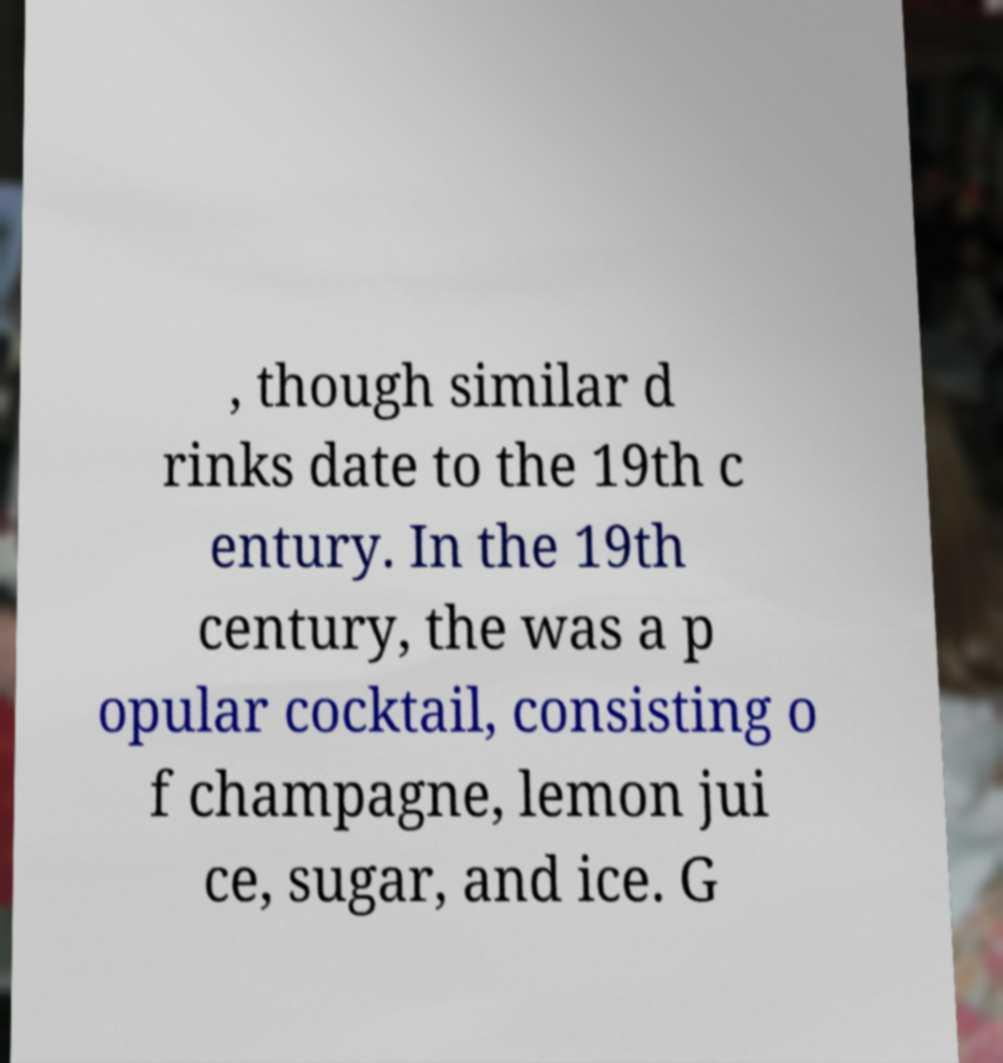Can you read and provide the text displayed in the image?This photo seems to have some interesting text. Can you extract and type it out for me? , though similar d rinks date to the 19th c entury. In the 19th century, the was a p opular cocktail, consisting o f champagne, lemon jui ce, sugar, and ice. G 